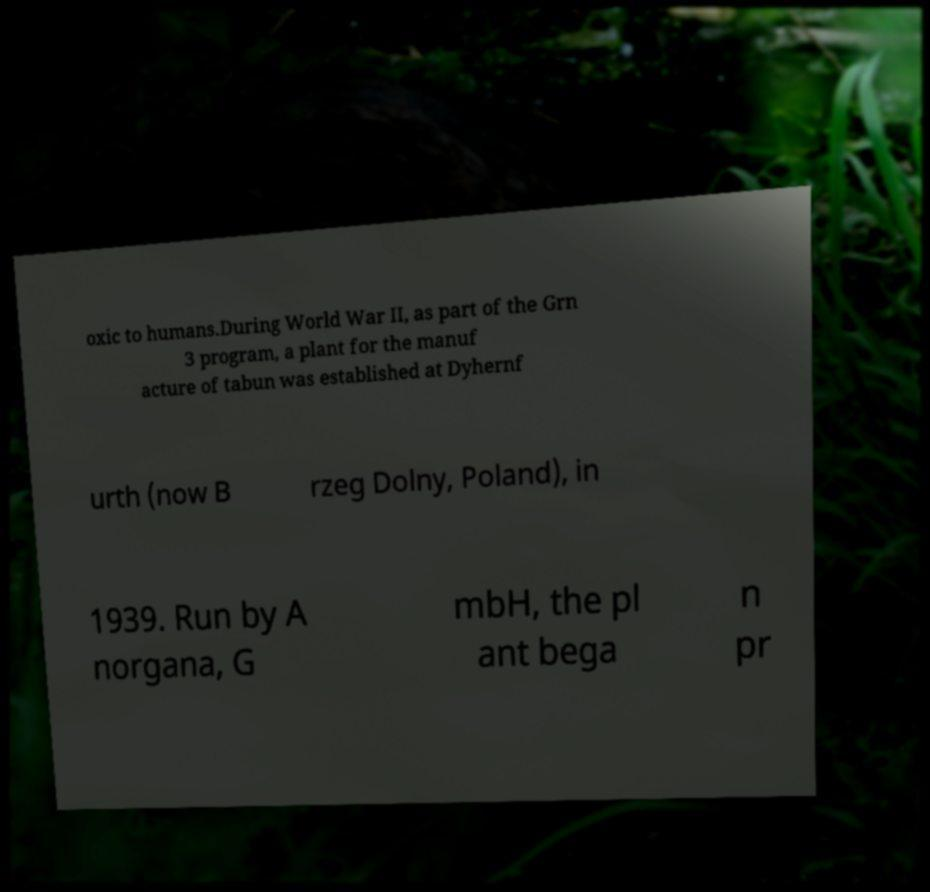What messages or text are displayed in this image? I need them in a readable, typed format. oxic to humans.During World War II, as part of the Grn 3 program, a plant for the manuf acture of tabun was established at Dyhernf urth (now B rzeg Dolny, Poland), in 1939. Run by A norgana, G mbH, the pl ant bega n pr 